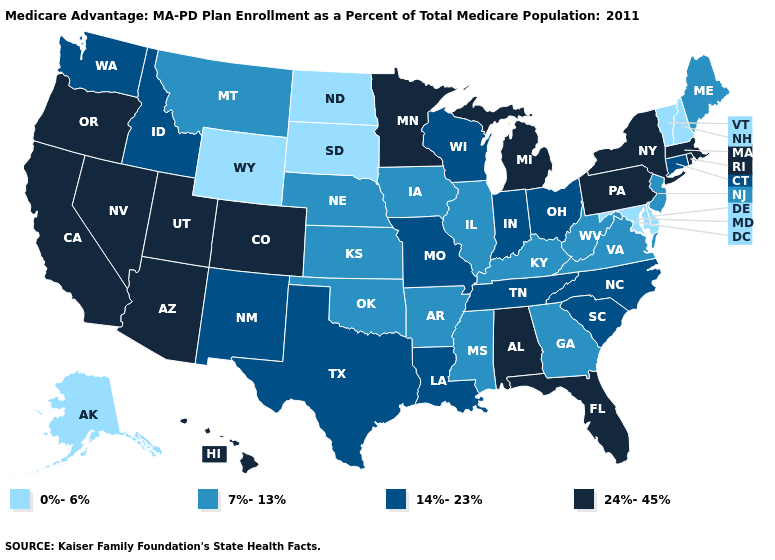Which states have the lowest value in the USA?
Concise answer only. Alaska, Delaware, Maryland, North Dakota, New Hampshire, South Dakota, Vermont, Wyoming. What is the lowest value in the MidWest?
Keep it brief. 0%-6%. Which states hav the highest value in the West?
Answer briefly. Arizona, California, Colorado, Hawaii, Nevada, Oregon, Utah. What is the lowest value in the MidWest?
Be succinct. 0%-6%. Name the states that have a value in the range 0%-6%?
Short answer required. Alaska, Delaware, Maryland, North Dakota, New Hampshire, South Dakota, Vermont, Wyoming. Is the legend a continuous bar?
Quick response, please. No. Does Mississippi have the same value as Georgia?
Answer briefly. Yes. What is the lowest value in the USA?
Answer briefly. 0%-6%. What is the lowest value in states that border Louisiana?
Short answer required. 7%-13%. Name the states that have a value in the range 24%-45%?
Answer briefly. Alabama, Arizona, California, Colorado, Florida, Hawaii, Massachusetts, Michigan, Minnesota, Nevada, New York, Oregon, Pennsylvania, Rhode Island, Utah. Name the states that have a value in the range 7%-13%?
Quick response, please. Arkansas, Georgia, Iowa, Illinois, Kansas, Kentucky, Maine, Mississippi, Montana, Nebraska, New Jersey, Oklahoma, Virginia, West Virginia. Which states have the lowest value in the USA?
Quick response, please. Alaska, Delaware, Maryland, North Dakota, New Hampshire, South Dakota, Vermont, Wyoming. What is the highest value in the Northeast ?
Concise answer only. 24%-45%. Name the states that have a value in the range 24%-45%?
Quick response, please. Alabama, Arizona, California, Colorado, Florida, Hawaii, Massachusetts, Michigan, Minnesota, Nevada, New York, Oregon, Pennsylvania, Rhode Island, Utah. Does Iowa have the highest value in the MidWest?
Quick response, please. No. 